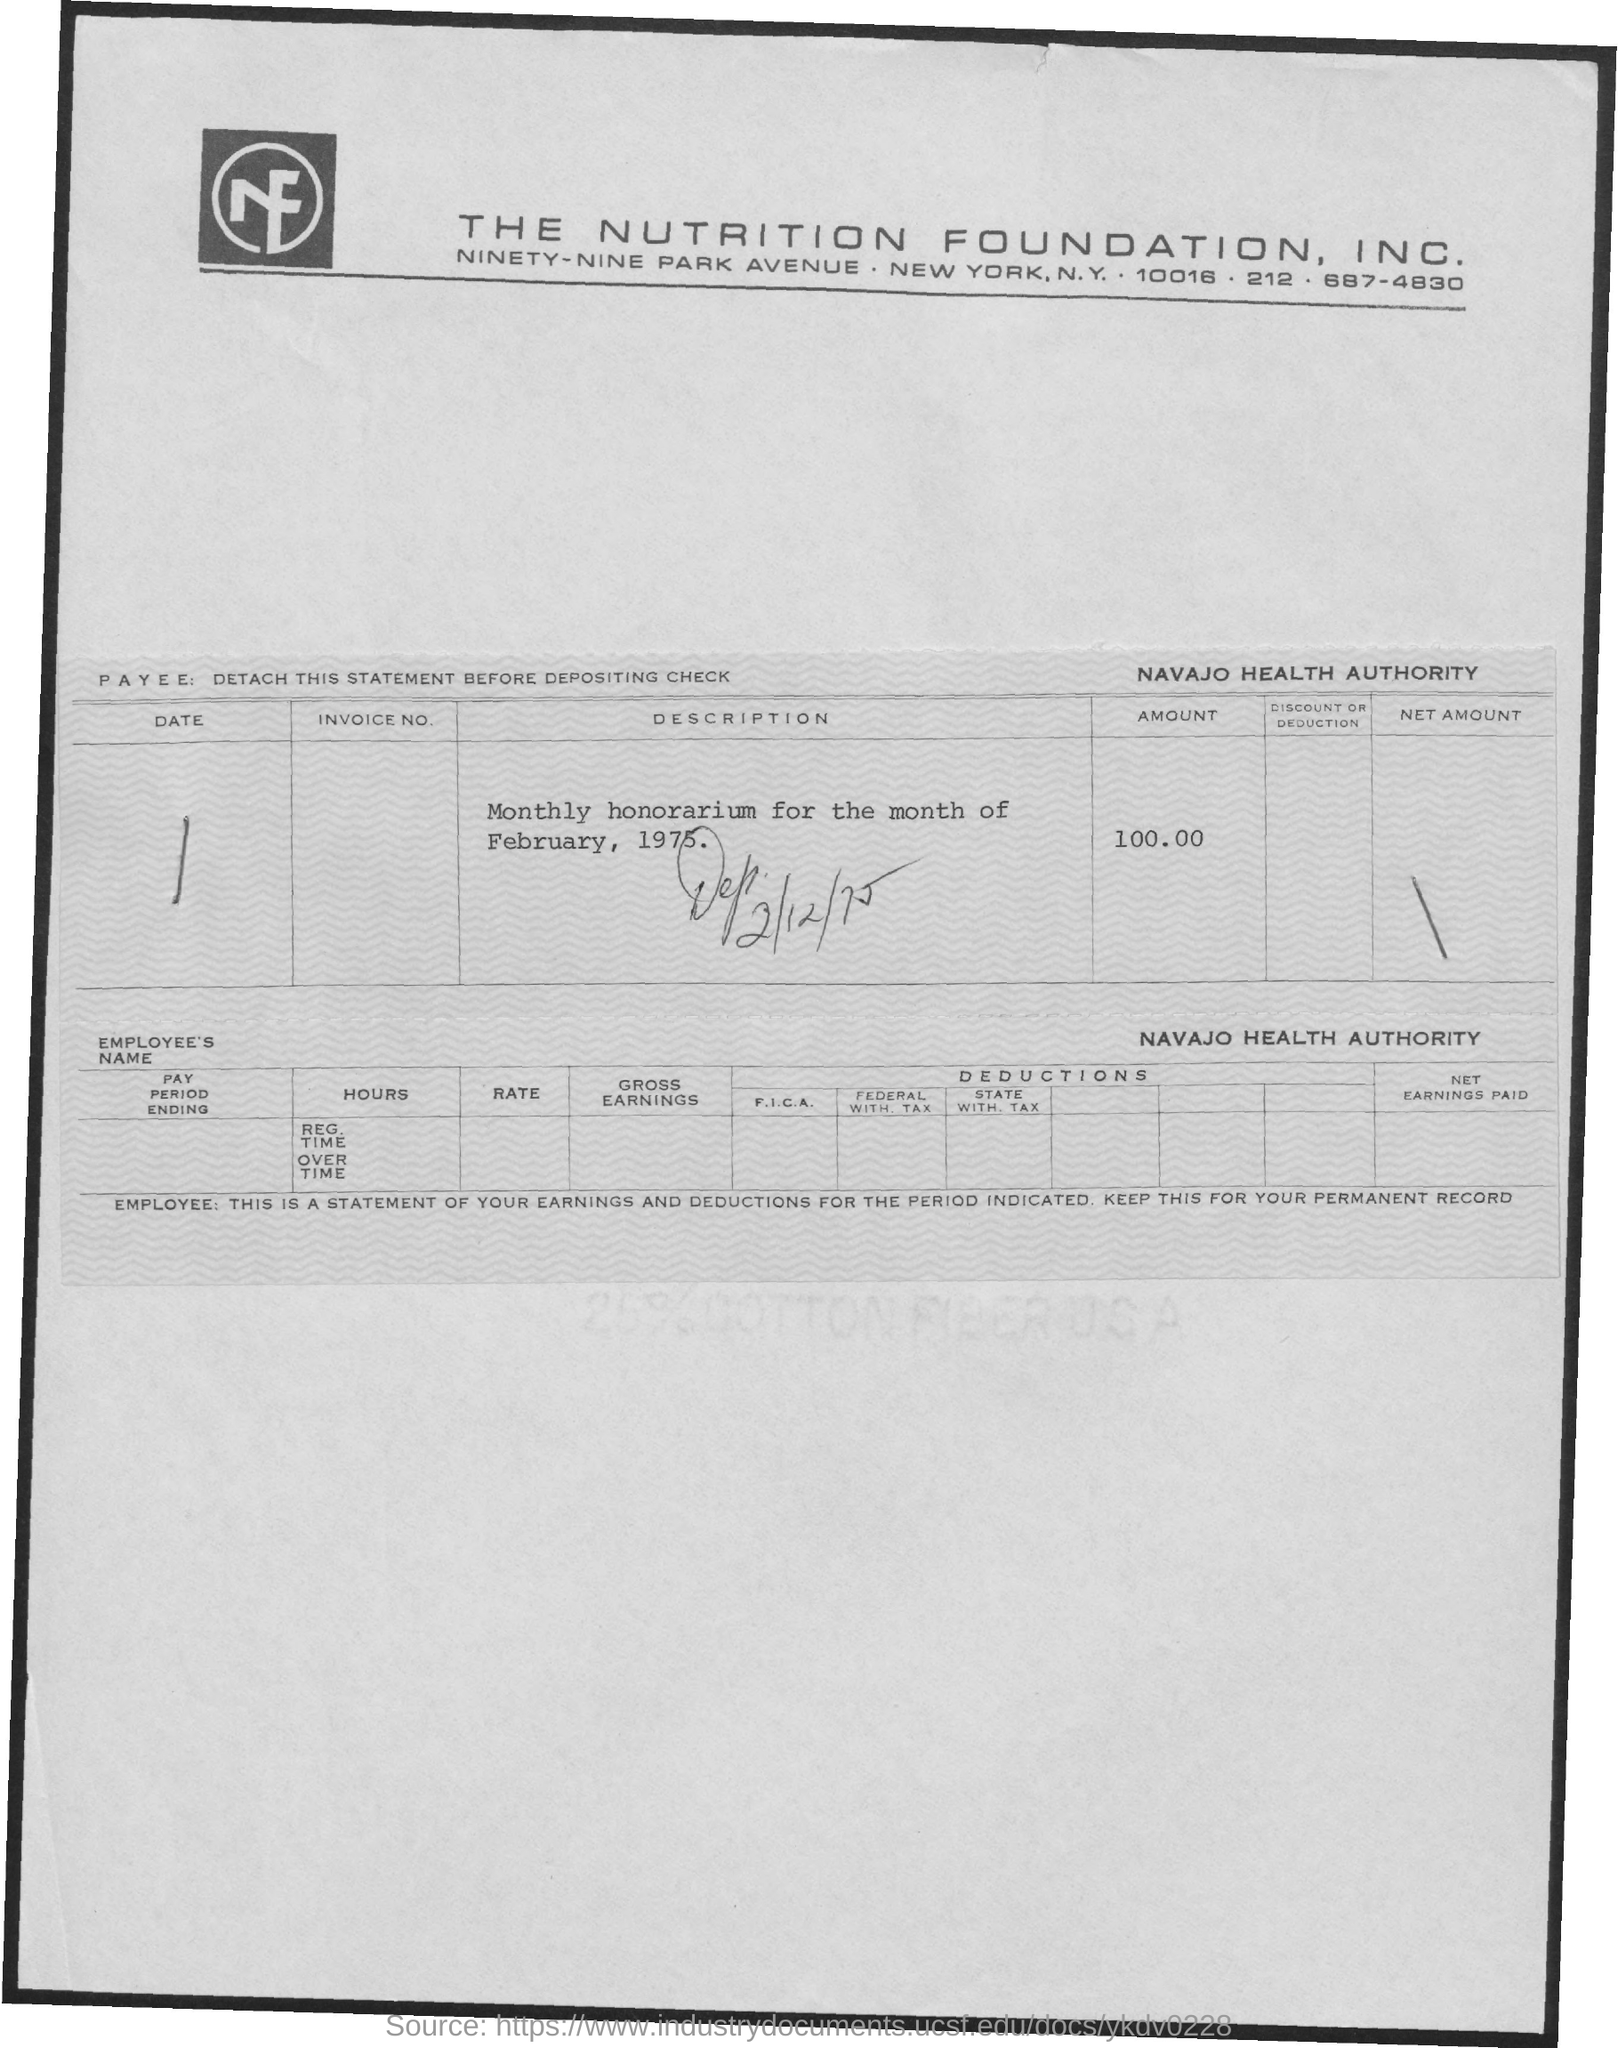What is the full-form of  nf?
Keep it short and to the point. Nutrition Foundation. What is the telephone number of the nutrition foundation inc.?
Offer a very short reply. 687-4830. What is the amount of monthly honorarium for month of february, 1975?
Your answer should be very brief. 100.00. What is the name of the health authority?
Ensure brevity in your answer.  Navajo Health Authority. 